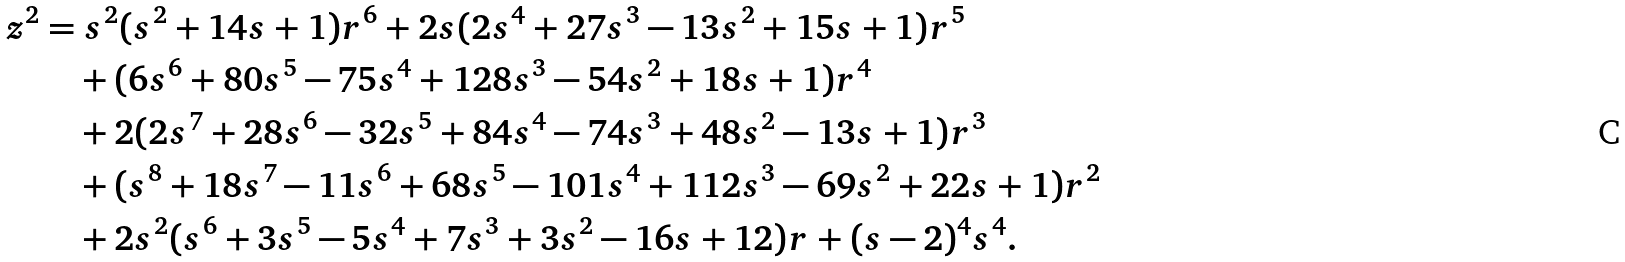Convert formula to latex. <formula><loc_0><loc_0><loc_500><loc_500>z ^ { 2 } & = s ^ { 2 } ( s ^ { 2 } + 1 4 s + 1 ) r ^ { 6 } + 2 s ( 2 s ^ { 4 } + 2 7 s ^ { 3 } - 1 3 s ^ { 2 } + 1 5 s + 1 ) r ^ { 5 } \\ & \quad + ( 6 s ^ { 6 } + 8 0 s ^ { 5 } - 7 5 s ^ { 4 } + 1 2 8 s ^ { 3 } - 5 4 s ^ { 2 } + 1 8 s + 1 ) r ^ { 4 } \\ & \quad + 2 ( 2 s ^ { 7 } + 2 8 s ^ { 6 } - 3 2 s ^ { 5 } + 8 4 s ^ { 4 } - 7 4 s ^ { 3 } + 4 8 s ^ { 2 } - 1 3 s + 1 ) r ^ { 3 } \\ & \quad + ( s ^ { 8 } + 1 8 s ^ { 7 } - 1 1 s ^ { 6 } + 6 8 s ^ { 5 } - 1 0 1 s ^ { 4 } + 1 1 2 s ^ { 3 } - 6 9 s ^ { 2 } + 2 2 s + 1 ) r ^ { 2 } \\ & \quad + 2 s ^ { 2 } ( s ^ { 6 } + 3 s ^ { 5 } - 5 s ^ { 4 } + 7 s ^ { 3 } + 3 s ^ { 2 } - 1 6 s + 1 2 ) r + ( s - 2 ) ^ { 4 } s ^ { 4 } .</formula> 